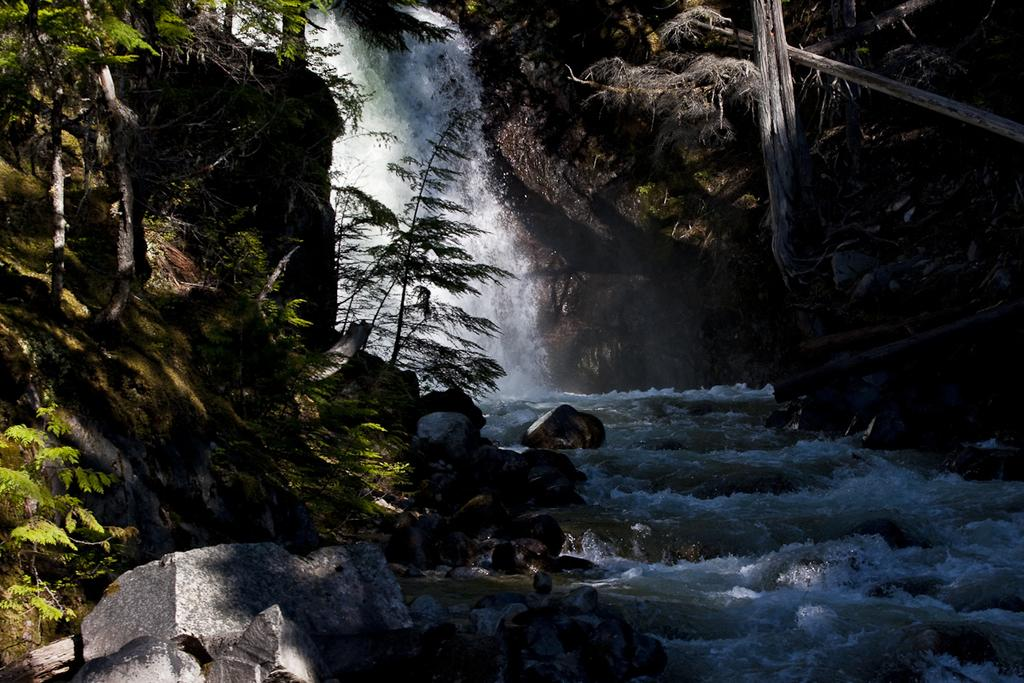What natural feature is the main subject of the image? There is a waterfall in the image. What other elements can be seen in the image? There are rocks and trees in the image. What type of quartz can be seen on the rocks near the waterfall in the image? There is no quartz visible on the rocks in the image. What type of cap is the waterfall wearing in the image? The waterfall is not wearing a cap in the image. 